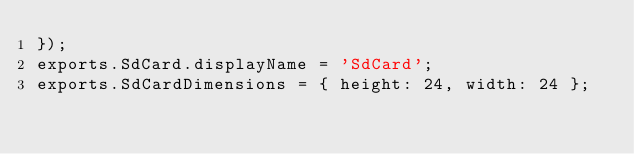Convert code to text. <code><loc_0><loc_0><loc_500><loc_500><_JavaScript_>});
exports.SdCard.displayName = 'SdCard';
exports.SdCardDimensions = { height: 24, width: 24 };
</code> 